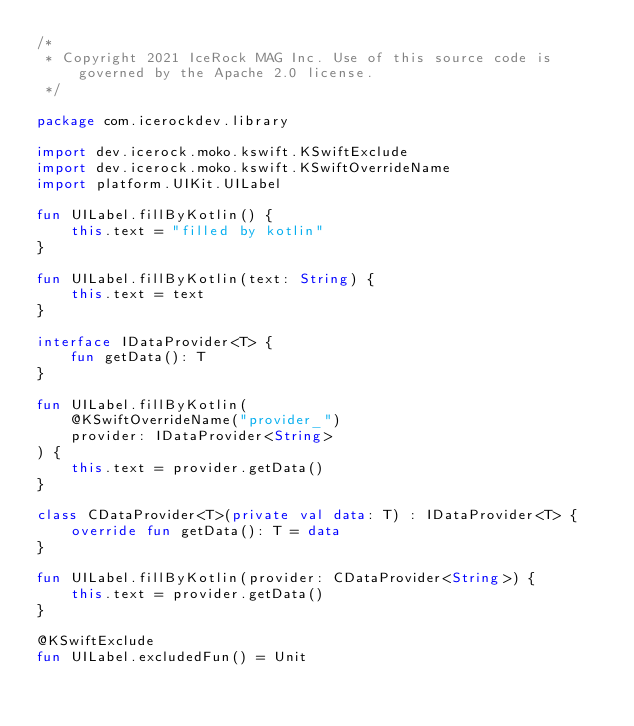Convert code to text. <code><loc_0><loc_0><loc_500><loc_500><_Kotlin_>/*
 * Copyright 2021 IceRock MAG Inc. Use of this source code is governed by the Apache 2.0 license.
 */

package com.icerockdev.library

import dev.icerock.moko.kswift.KSwiftExclude
import dev.icerock.moko.kswift.KSwiftOverrideName
import platform.UIKit.UILabel

fun UILabel.fillByKotlin() {
    this.text = "filled by kotlin"
}

fun UILabel.fillByKotlin(text: String) {
    this.text = text
}

interface IDataProvider<T> {
    fun getData(): T
}

fun UILabel.fillByKotlin(
    @KSwiftOverrideName("provider_")
    provider: IDataProvider<String>
) {
    this.text = provider.getData()
}

class CDataProvider<T>(private val data: T) : IDataProvider<T> {
    override fun getData(): T = data
}

fun UILabel.fillByKotlin(provider: CDataProvider<String>) {
    this.text = provider.getData()
}

@KSwiftExclude
fun UILabel.excludedFun() = Unit
</code> 